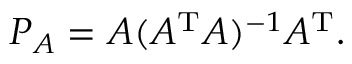Convert formula to latex. <formula><loc_0><loc_0><loc_500><loc_500>P _ { A } = A ( A ^ { T } A ) ^ { - 1 } A ^ { T } .</formula> 